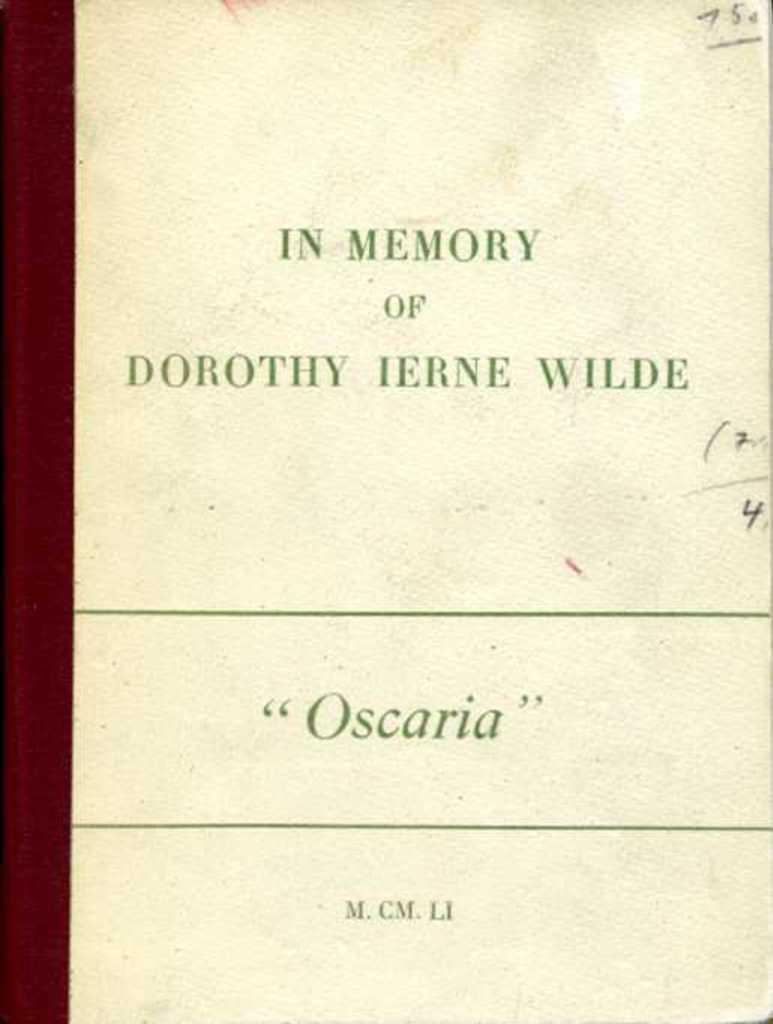Provide a one-sentence caption for the provided image. A book dedication is written above the title "Oscaria" on a slightly dirty page. 